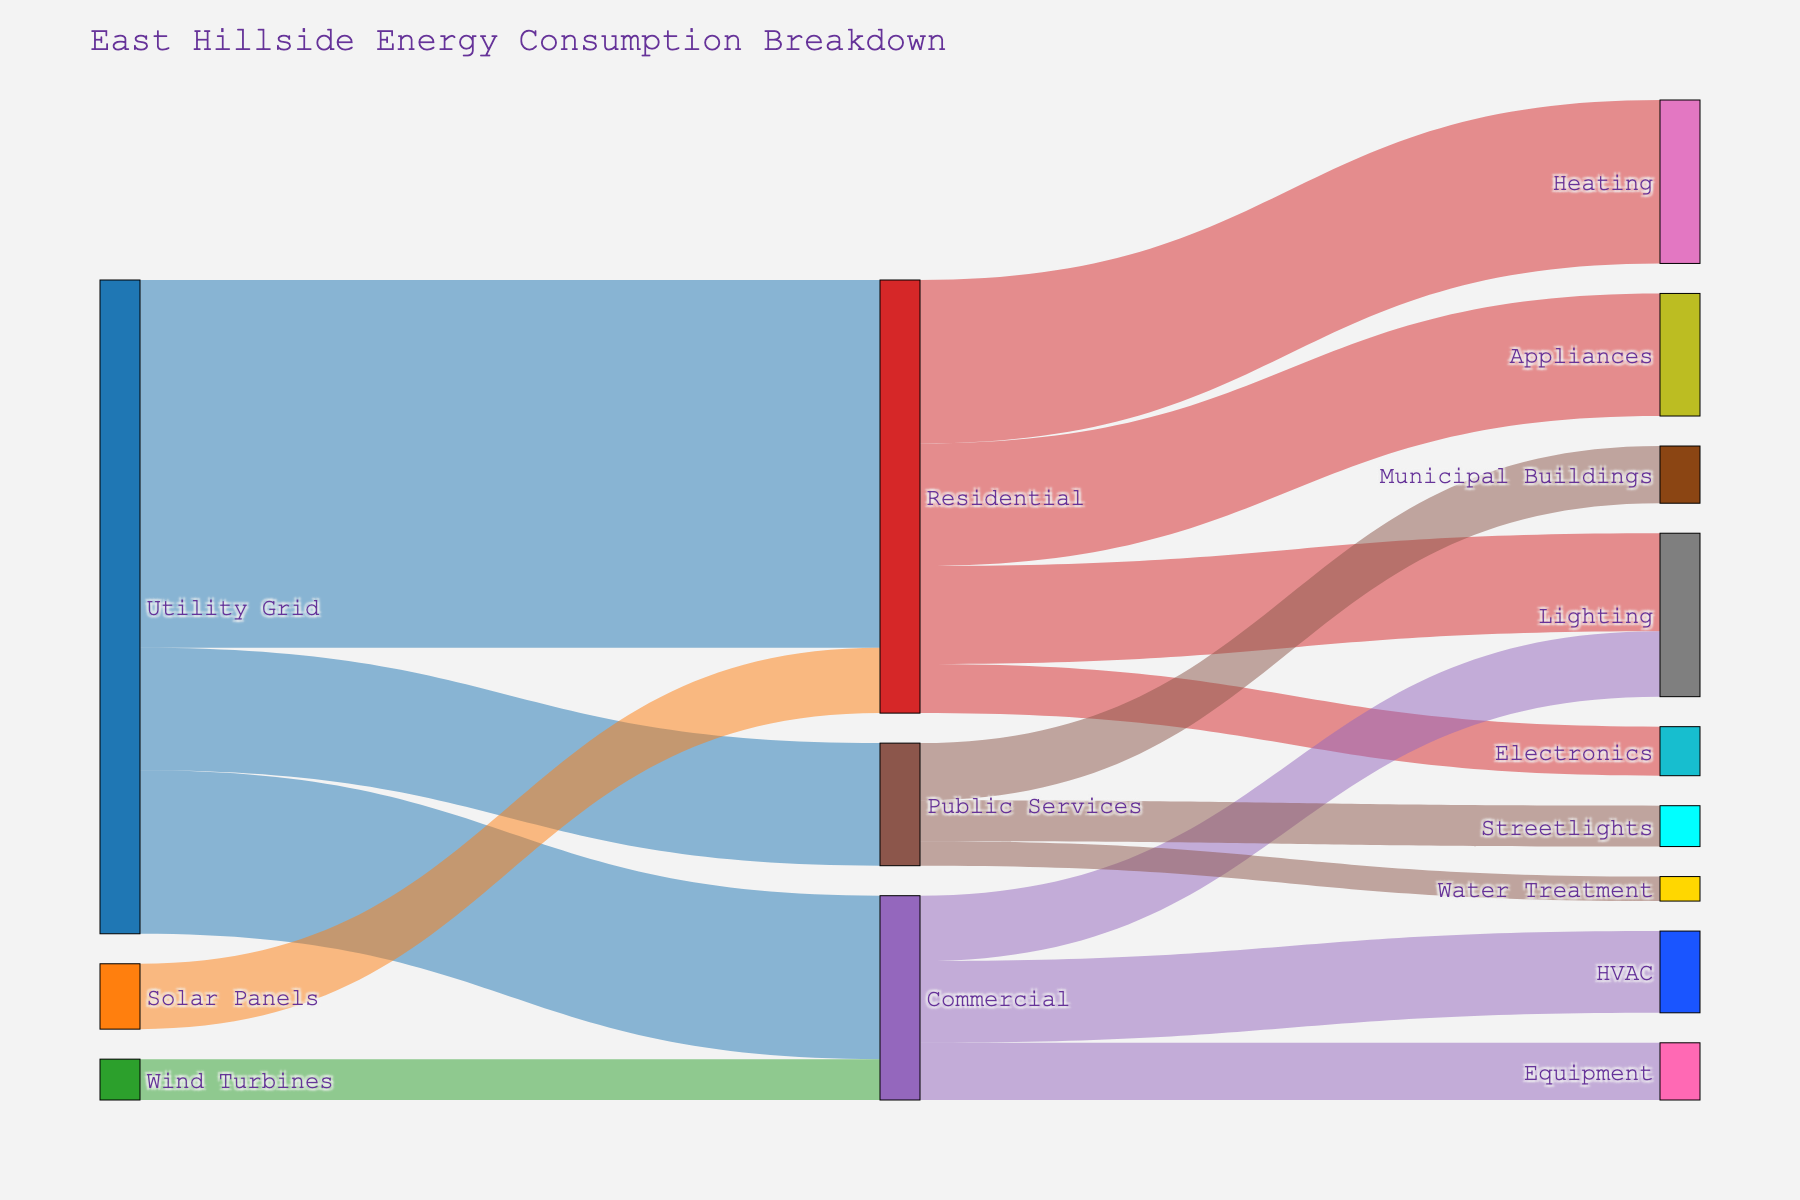What's the overall title of the figure? The title is typically displayed at the top of the figure and provides a summary of what the figure represents. In this case, it is "East Hillside Energy Consumption Breakdown".
Answer: "East Hillside Energy Consumption Breakdown" How much energy from the Utility Grid goes to Residential use? The Sankey diagram shows energy flow, with the width of the arrows indicating the amount of energy. By looking at the arrow from the Utility Grid to Residential, we see it is labeled with a value of 45.
Answer: 45 What's the combined energy consumption for heating and lighting in the Residential category? To answer this, sum the values for Heating and Lighting in the Residential category. Heating is 20 and Lighting is 12, so 20 + 12 = 32.
Answer: 32 Which energy source provides the least amount of energy and to which category does it go? By looking at the values on the arrows from the energy sources, the smallest value is 5 from Wind Turbines to Commercial.
Answer: Wind Turbines to Commercial Compare the energy consumed by HVAC in Commercial versus Heating in Residential. Which one is higher and by how much? HVAC in Commercial consumes 10 units, and Heating in Residential consumes 20 units. The difference is 20 - 10 = 10 units, with Heating being higher.
Answer: Heating in Residential by 10 units How much energy is used for appliances in the Residential category? The diagram shows an arrow from Residential to Appliances, labeled with a value of 15.
Answer: 15 What is the total amount of energy coming from renewable sources (Solar Panels and Wind Turbines)? Sum the energy from Solar Panels and Wind Turbines. Solar Panels contribute 8 and Wind Turbines 5, so 8 + 5 = 13.
Answer: 13 Is the energy consumption for Electronics in Residential greater than for Equipment in Commercial? The Sankey diagram shows Electronics in Residential consumes 6 units, while Equipment in Commercial consumes 7 units. Since 7 is greater than 6, Electronics is not greater.
Answer: No How much total energy does the Public Services category consume? Sum the values for all Public Services categories: Streetlights (5), Municipal Buildings (7), and Water Treatment (3). Therefore, 5 + 7 + 3 = 15.
Answer: 15 Which category consumes the most energy from the Utility Grid, and what is the value? Compare the values of energy from the Utility Grid to each category. Residential consumes 45, Commercial 20, and Public Services 15. The highest consumption is Residential with 45 units.
Answer: Residential with 45 units 